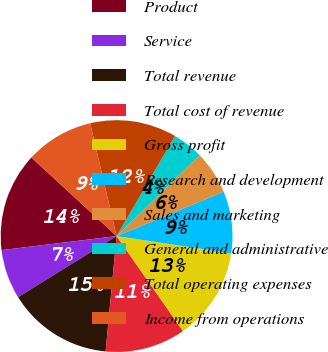Convert chart to OTSL. <chart><loc_0><loc_0><loc_500><loc_500><pie_chart><fcel>Product<fcel>Service<fcel>Total revenue<fcel>Total cost of revenue<fcel>Gross profit<fcel>Research and development<fcel>Sales and marketing<fcel>General and administrative<fcel>Total operating expenses<fcel>Income from operations<nl><fcel>13.79%<fcel>6.9%<fcel>14.66%<fcel>11.21%<fcel>12.93%<fcel>8.62%<fcel>6.03%<fcel>4.31%<fcel>12.07%<fcel>9.48%<nl></chart> 